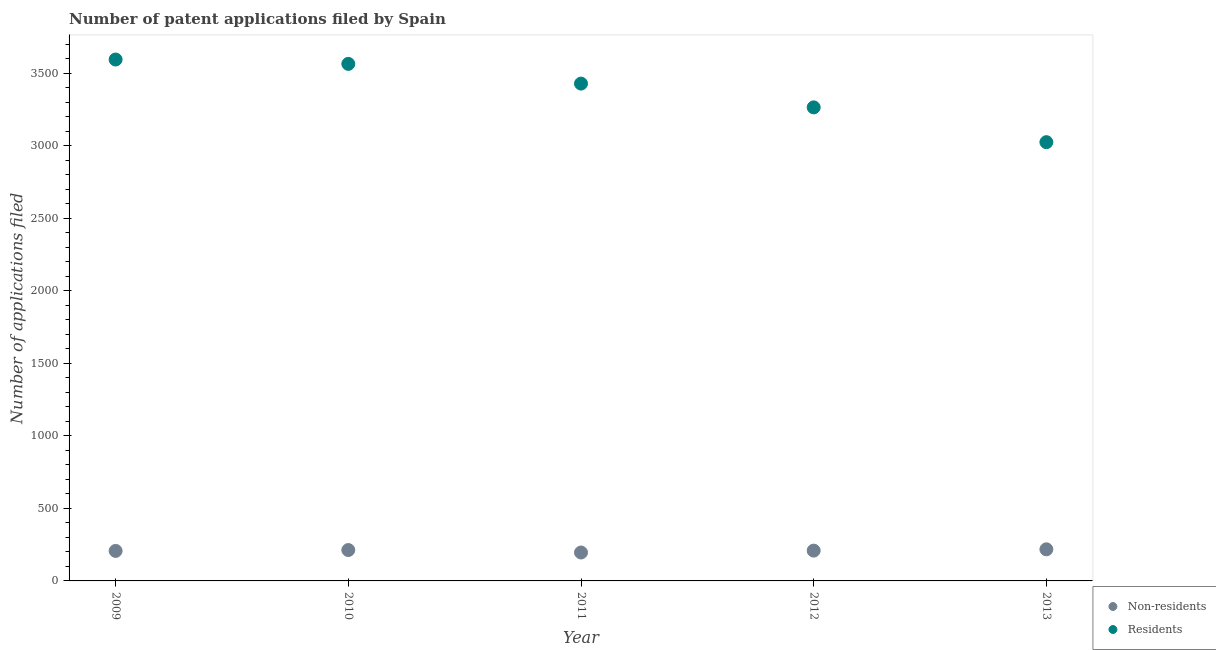How many different coloured dotlines are there?
Offer a very short reply. 2. Is the number of dotlines equal to the number of legend labels?
Give a very brief answer. Yes. What is the number of patent applications by residents in 2009?
Your answer should be compact. 3596. Across all years, what is the maximum number of patent applications by non residents?
Give a very brief answer. 218. Across all years, what is the minimum number of patent applications by residents?
Provide a succinct answer. 3026. What is the total number of patent applications by non residents in the graph?
Keep it short and to the point. 1043. What is the difference between the number of patent applications by residents in 2009 and that in 2010?
Make the answer very short. 30. What is the difference between the number of patent applications by non residents in 2011 and the number of patent applications by residents in 2009?
Offer a very short reply. -3400. What is the average number of patent applications by non residents per year?
Keep it short and to the point. 208.6. In the year 2012, what is the difference between the number of patent applications by residents and number of patent applications by non residents?
Make the answer very short. 3057. What is the ratio of the number of patent applications by residents in 2009 to that in 2012?
Your response must be concise. 1.1. Is the difference between the number of patent applications by non residents in 2009 and 2012 greater than the difference between the number of patent applications by residents in 2009 and 2012?
Provide a short and direct response. No. What is the difference between the highest and the second highest number of patent applications by non residents?
Provide a succinct answer. 5. What is the difference between the highest and the lowest number of patent applications by non residents?
Offer a very short reply. 22. Is the sum of the number of patent applications by residents in 2010 and 2012 greater than the maximum number of patent applications by non residents across all years?
Provide a succinct answer. Yes. Is the number of patent applications by residents strictly greater than the number of patent applications by non residents over the years?
Keep it short and to the point. Yes. How many dotlines are there?
Your answer should be very brief. 2. How many years are there in the graph?
Offer a terse response. 5. Does the graph contain any zero values?
Ensure brevity in your answer.  No. Where does the legend appear in the graph?
Provide a succinct answer. Bottom right. How many legend labels are there?
Provide a short and direct response. 2. How are the legend labels stacked?
Keep it short and to the point. Vertical. What is the title of the graph?
Ensure brevity in your answer.  Number of patent applications filed by Spain. What is the label or title of the X-axis?
Provide a short and direct response. Year. What is the label or title of the Y-axis?
Keep it short and to the point. Number of applications filed. What is the Number of applications filed of Non-residents in 2009?
Make the answer very short. 207. What is the Number of applications filed in Residents in 2009?
Provide a short and direct response. 3596. What is the Number of applications filed in Non-residents in 2010?
Your response must be concise. 213. What is the Number of applications filed in Residents in 2010?
Your answer should be very brief. 3566. What is the Number of applications filed in Non-residents in 2011?
Your response must be concise. 196. What is the Number of applications filed of Residents in 2011?
Your response must be concise. 3430. What is the Number of applications filed of Non-residents in 2012?
Provide a succinct answer. 209. What is the Number of applications filed in Residents in 2012?
Offer a very short reply. 3266. What is the Number of applications filed in Non-residents in 2013?
Ensure brevity in your answer.  218. What is the Number of applications filed of Residents in 2013?
Your answer should be very brief. 3026. Across all years, what is the maximum Number of applications filed of Non-residents?
Your answer should be very brief. 218. Across all years, what is the maximum Number of applications filed in Residents?
Your answer should be compact. 3596. Across all years, what is the minimum Number of applications filed in Non-residents?
Your response must be concise. 196. Across all years, what is the minimum Number of applications filed of Residents?
Your answer should be compact. 3026. What is the total Number of applications filed in Non-residents in the graph?
Ensure brevity in your answer.  1043. What is the total Number of applications filed in Residents in the graph?
Give a very brief answer. 1.69e+04. What is the difference between the Number of applications filed of Non-residents in 2009 and that in 2010?
Provide a short and direct response. -6. What is the difference between the Number of applications filed of Non-residents in 2009 and that in 2011?
Your response must be concise. 11. What is the difference between the Number of applications filed of Residents in 2009 and that in 2011?
Keep it short and to the point. 166. What is the difference between the Number of applications filed of Non-residents in 2009 and that in 2012?
Give a very brief answer. -2. What is the difference between the Number of applications filed of Residents in 2009 and that in 2012?
Your answer should be very brief. 330. What is the difference between the Number of applications filed of Residents in 2009 and that in 2013?
Provide a short and direct response. 570. What is the difference between the Number of applications filed in Residents in 2010 and that in 2011?
Offer a very short reply. 136. What is the difference between the Number of applications filed in Non-residents in 2010 and that in 2012?
Give a very brief answer. 4. What is the difference between the Number of applications filed in Residents in 2010 and that in 2012?
Offer a terse response. 300. What is the difference between the Number of applications filed in Non-residents in 2010 and that in 2013?
Keep it short and to the point. -5. What is the difference between the Number of applications filed of Residents in 2010 and that in 2013?
Your response must be concise. 540. What is the difference between the Number of applications filed in Residents in 2011 and that in 2012?
Make the answer very short. 164. What is the difference between the Number of applications filed of Residents in 2011 and that in 2013?
Provide a succinct answer. 404. What is the difference between the Number of applications filed of Non-residents in 2012 and that in 2013?
Ensure brevity in your answer.  -9. What is the difference between the Number of applications filed in Residents in 2012 and that in 2013?
Make the answer very short. 240. What is the difference between the Number of applications filed in Non-residents in 2009 and the Number of applications filed in Residents in 2010?
Offer a very short reply. -3359. What is the difference between the Number of applications filed of Non-residents in 2009 and the Number of applications filed of Residents in 2011?
Give a very brief answer. -3223. What is the difference between the Number of applications filed in Non-residents in 2009 and the Number of applications filed in Residents in 2012?
Ensure brevity in your answer.  -3059. What is the difference between the Number of applications filed of Non-residents in 2009 and the Number of applications filed of Residents in 2013?
Your answer should be compact. -2819. What is the difference between the Number of applications filed of Non-residents in 2010 and the Number of applications filed of Residents in 2011?
Keep it short and to the point. -3217. What is the difference between the Number of applications filed in Non-residents in 2010 and the Number of applications filed in Residents in 2012?
Your response must be concise. -3053. What is the difference between the Number of applications filed in Non-residents in 2010 and the Number of applications filed in Residents in 2013?
Offer a very short reply. -2813. What is the difference between the Number of applications filed in Non-residents in 2011 and the Number of applications filed in Residents in 2012?
Give a very brief answer. -3070. What is the difference between the Number of applications filed in Non-residents in 2011 and the Number of applications filed in Residents in 2013?
Provide a short and direct response. -2830. What is the difference between the Number of applications filed of Non-residents in 2012 and the Number of applications filed of Residents in 2013?
Offer a very short reply. -2817. What is the average Number of applications filed in Non-residents per year?
Ensure brevity in your answer.  208.6. What is the average Number of applications filed of Residents per year?
Give a very brief answer. 3376.8. In the year 2009, what is the difference between the Number of applications filed in Non-residents and Number of applications filed in Residents?
Your response must be concise. -3389. In the year 2010, what is the difference between the Number of applications filed in Non-residents and Number of applications filed in Residents?
Provide a short and direct response. -3353. In the year 2011, what is the difference between the Number of applications filed in Non-residents and Number of applications filed in Residents?
Keep it short and to the point. -3234. In the year 2012, what is the difference between the Number of applications filed in Non-residents and Number of applications filed in Residents?
Offer a terse response. -3057. In the year 2013, what is the difference between the Number of applications filed in Non-residents and Number of applications filed in Residents?
Give a very brief answer. -2808. What is the ratio of the Number of applications filed of Non-residents in 2009 to that in 2010?
Provide a short and direct response. 0.97. What is the ratio of the Number of applications filed of Residents in 2009 to that in 2010?
Keep it short and to the point. 1.01. What is the ratio of the Number of applications filed of Non-residents in 2009 to that in 2011?
Your answer should be compact. 1.06. What is the ratio of the Number of applications filed of Residents in 2009 to that in 2011?
Offer a very short reply. 1.05. What is the ratio of the Number of applications filed of Non-residents in 2009 to that in 2012?
Provide a succinct answer. 0.99. What is the ratio of the Number of applications filed of Residents in 2009 to that in 2012?
Offer a terse response. 1.1. What is the ratio of the Number of applications filed in Non-residents in 2009 to that in 2013?
Ensure brevity in your answer.  0.95. What is the ratio of the Number of applications filed in Residents in 2009 to that in 2013?
Give a very brief answer. 1.19. What is the ratio of the Number of applications filed in Non-residents in 2010 to that in 2011?
Your response must be concise. 1.09. What is the ratio of the Number of applications filed in Residents in 2010 to that in 2011?
Make the answer very short. 1.04. What is the ratio of the Number of applications filed of Non-residents in 2010 to that in 2012?
Give a very brief answer. 1.02. What is the ratio of the Number of applications filed in Residents in 2010 to that in 2012?
Ensure brevity in your answer.  1.09. What is the ratio of the Number of applications filed of Non-residents in 2010 to that in 2013?
Offer a terse response. 0.98. What is the ratio of the Number of applications filed of Residents in 2010 to that in 2013?
Your answer should be compact. 1.18. What is the ratio of the Number of applications filed in Non-residents in 2011 to that in 2012?
Make the answer very short. 0.94. What is the ratio of the Number of applications filed of Residents in 2011 to that in 2012?
Your answer should be compact. 1.05. What is the ratio of the Number of applications filed in Non-residents in 2011 to that in 2013?
Provide a succinct answer. 0.9. What is the ratio of the Number of applications filed of Residents in 2011 to that in 2013?
Your answer should be very brief. 1.13. What is the ratio of the Number of applications filed in Non-residents in 2012 to that in 2013?
Your answer should be compact. 0.96. What is the ratio of the Number of applications filed of Residents in 2012 to that in 2013?
Make the answer very short. 1.08. What is the difference between the highest and the second highest Number of applications filed in Non-residents?
Your answer should be compact. 5. What is the difference between the highest and the second highest Number of applications filed in Residents?
Your answer should be compact. 30. What is the difference between the highest and the lowest Number of applications filed in Residents?
Your answer should be compact. 570. 